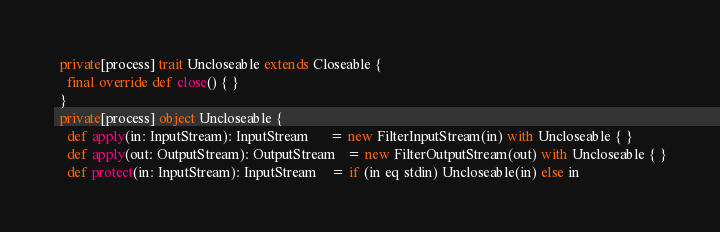Convert code to text. <code><loc_0><loc_0><loc_500><loc_500><_Scala_>  private[process] trait Uncloseable extends Closeable {
    final override def close() { }
  }
  private[process] object Uncloseable {
    def apply(in: InputStream): InputStream      = new FilterInputStream(in) with Uncloseable { }
    def apply(out: OutputStream): OutputStream   = new FilterOutputStream(out) with Uncloseable { }
    def protect(in: InputStream): InputStream    = if (in eq stdin) Uncloseable(in) else in</code> 